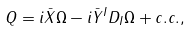Convert formula to latex. <formula><loc_0><loc_0><loc_500><loc_500>Q = i \bar { X } \Omega - i \bar { Y } ^ { I } D _ { I } \Omega + c . c . ,</formula> 